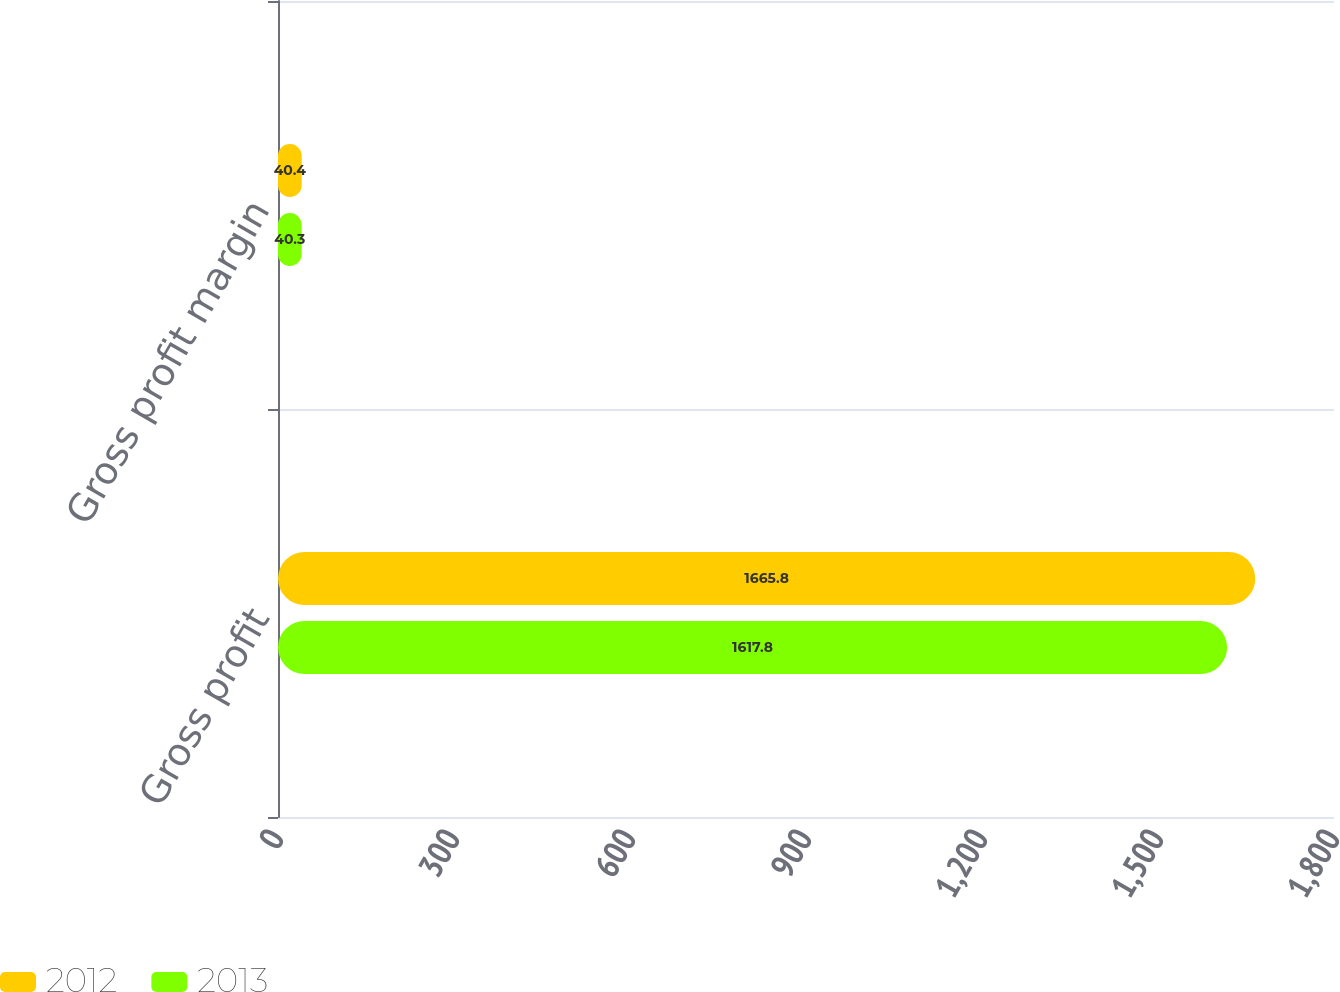Convert chart to OTSL. <chart><loc_0><loc_0><loc_500><loc_500><stacked_bar_chart><ecel><fcel>Gross profit<fcel>Gross profit margin<nl><fcel>2012<fcel>1665.8<fcel>40.4<nl><fcel>2013<fcel>1617.8<fcel>40.3<nl></chart> 